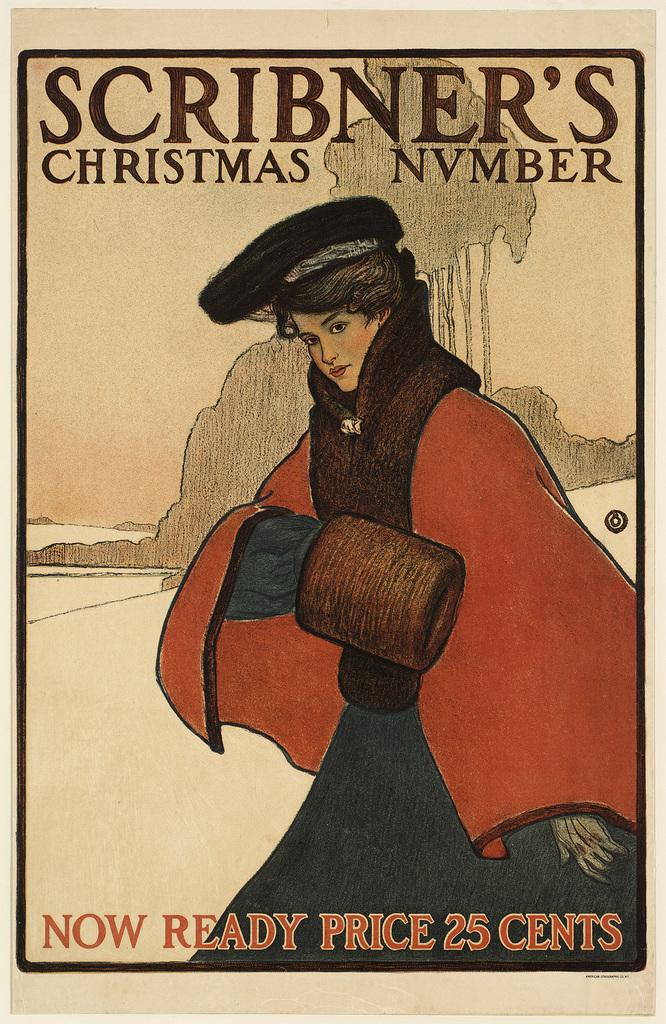What is the main subject of the image? The main subject of the image is a sketch of a person. What additional information is included on the sketch? There is text written on the sketch. What type of rhythm is the person in the sketch dancing to? There is no indication of rhythm or dancing in the image; it is a sketch of a person with text written on it. 